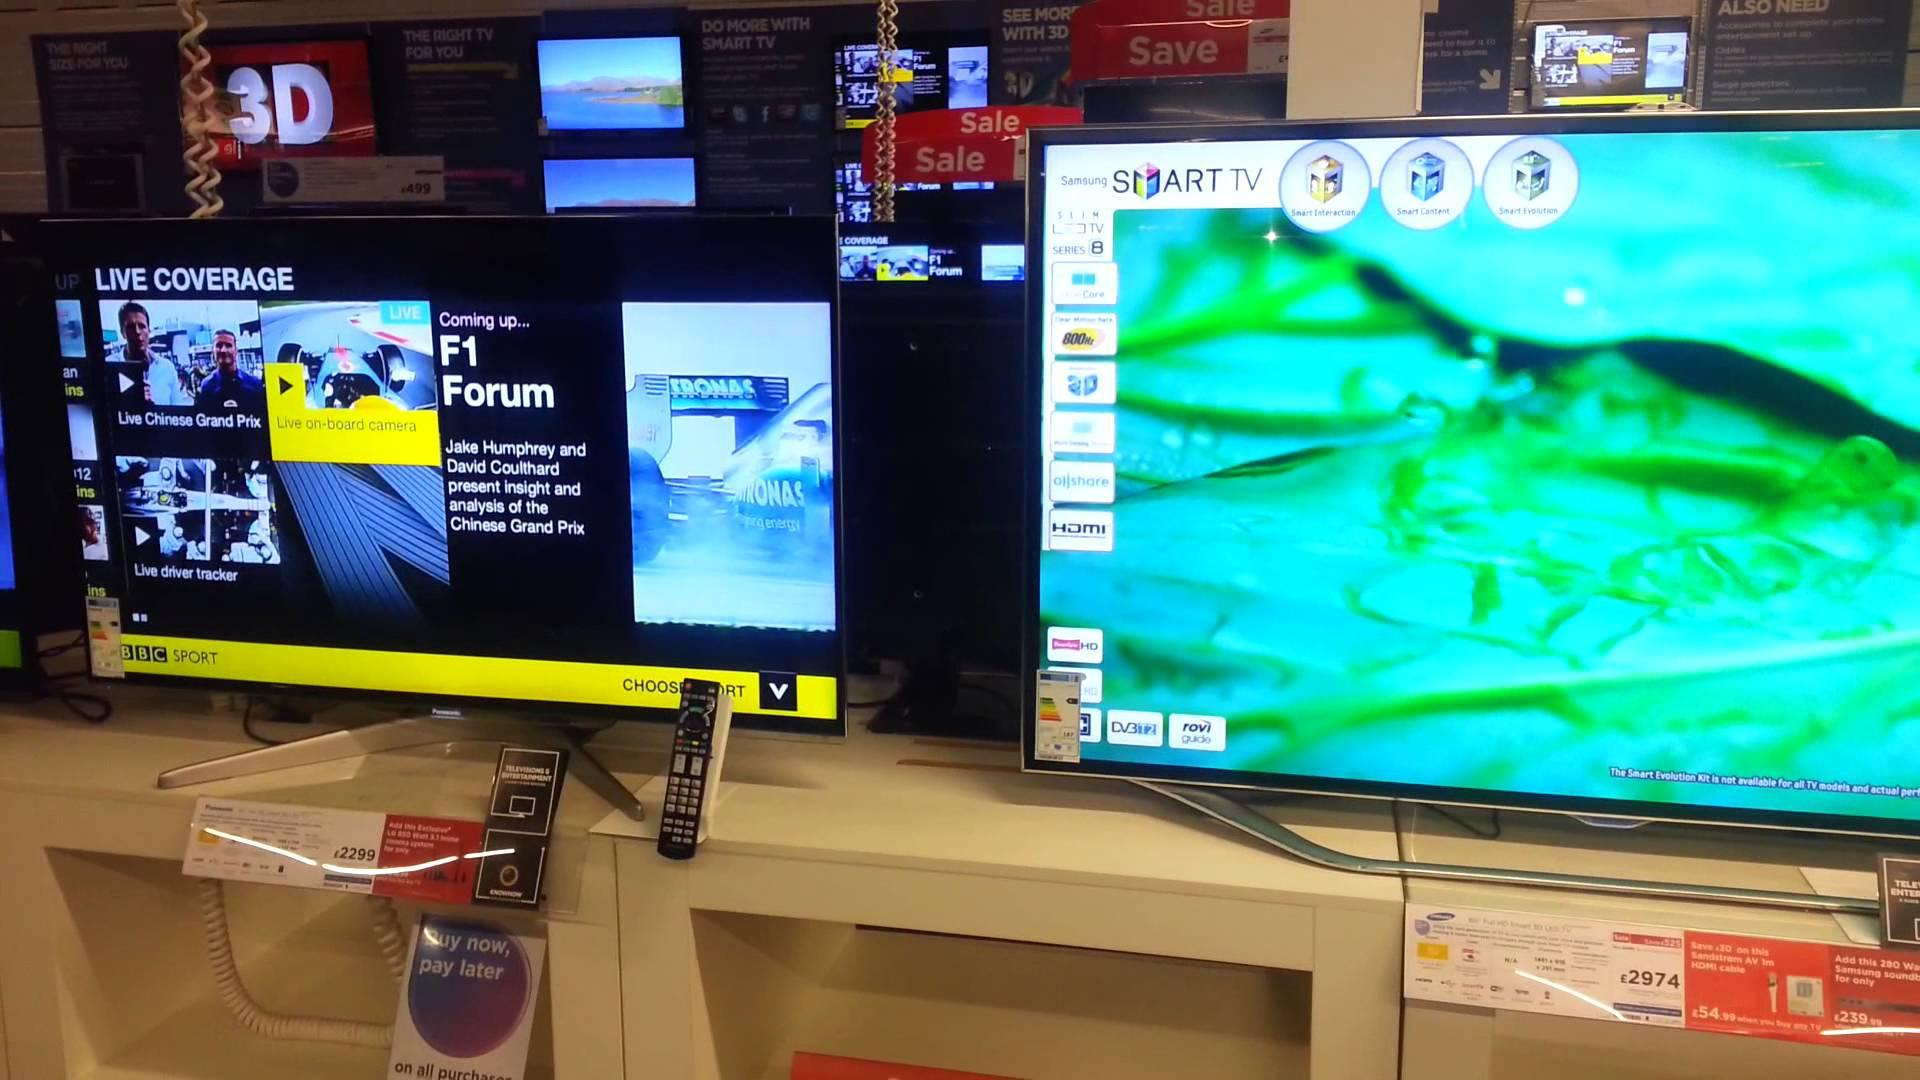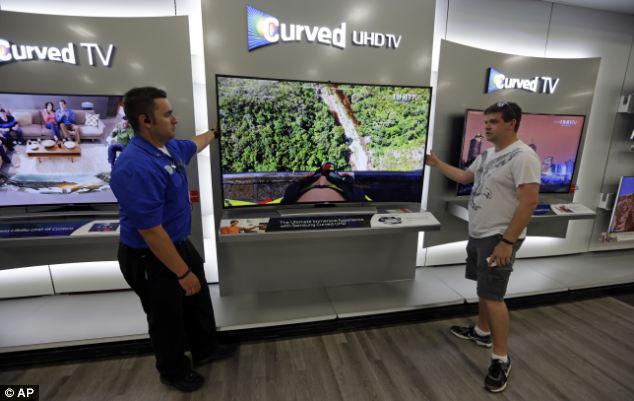The first image is the image on the left, the second image is the image on the right. Evaluate the accuracy of this statement regarding the images: "An image shows at least one man standing by a screen display.". Is it true? Answer yes or no. Yes. The first image is the image on the left, the second image is the image on the right. Assess this claim about the two images: "A single person is shown with some televisions.". Correct or not? Answer yes or no. No. 